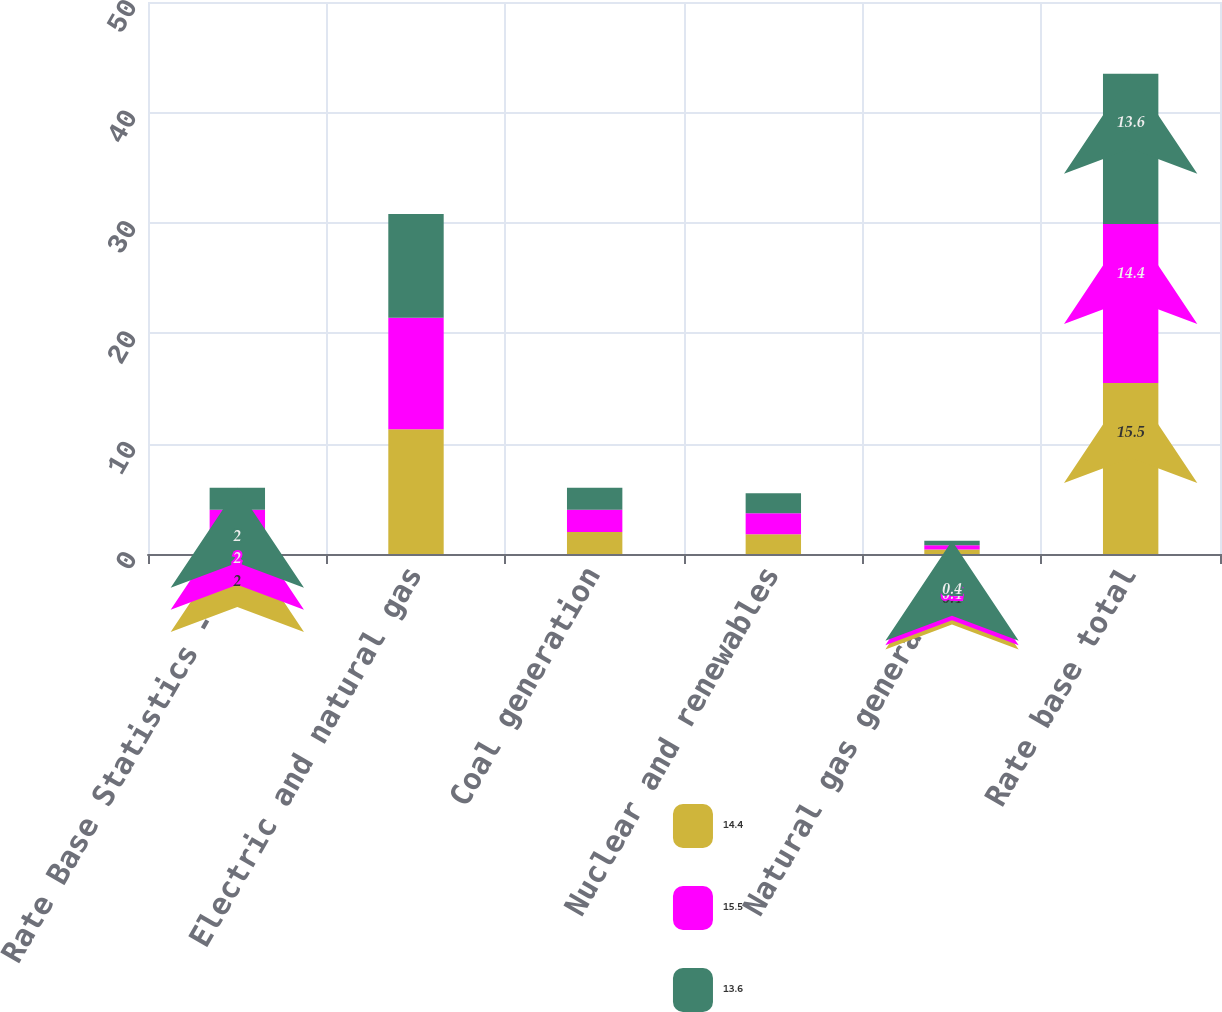Convert chart to OTSL. <chart><loc_0><loc_0><loc_500><loc_500><stacked_bar_chart><ecel><fcel>Rate Base Statistics - At<fcel>Electric and natural gas<fcel>Coal generation<fcel>Nuclear and renewables<fcel>Natural gas generation<fcel>Rate base total<nl><fcel>14.4<fcel>2<fcel>11.3<fcel>2<fcel>1.8<fcel>0.4<fcel>15.5<nl><fcel>15.5<fcel>2<fcel>10.1<fcel>2<fcel>1.9<fcel>0.4<fcel>14.4<nl><fcel>13.6<fcel>2<fcel>9.4<fcel>2<fcel>1.8<fcel>0.4<fcel>13.6<nl></chart> 